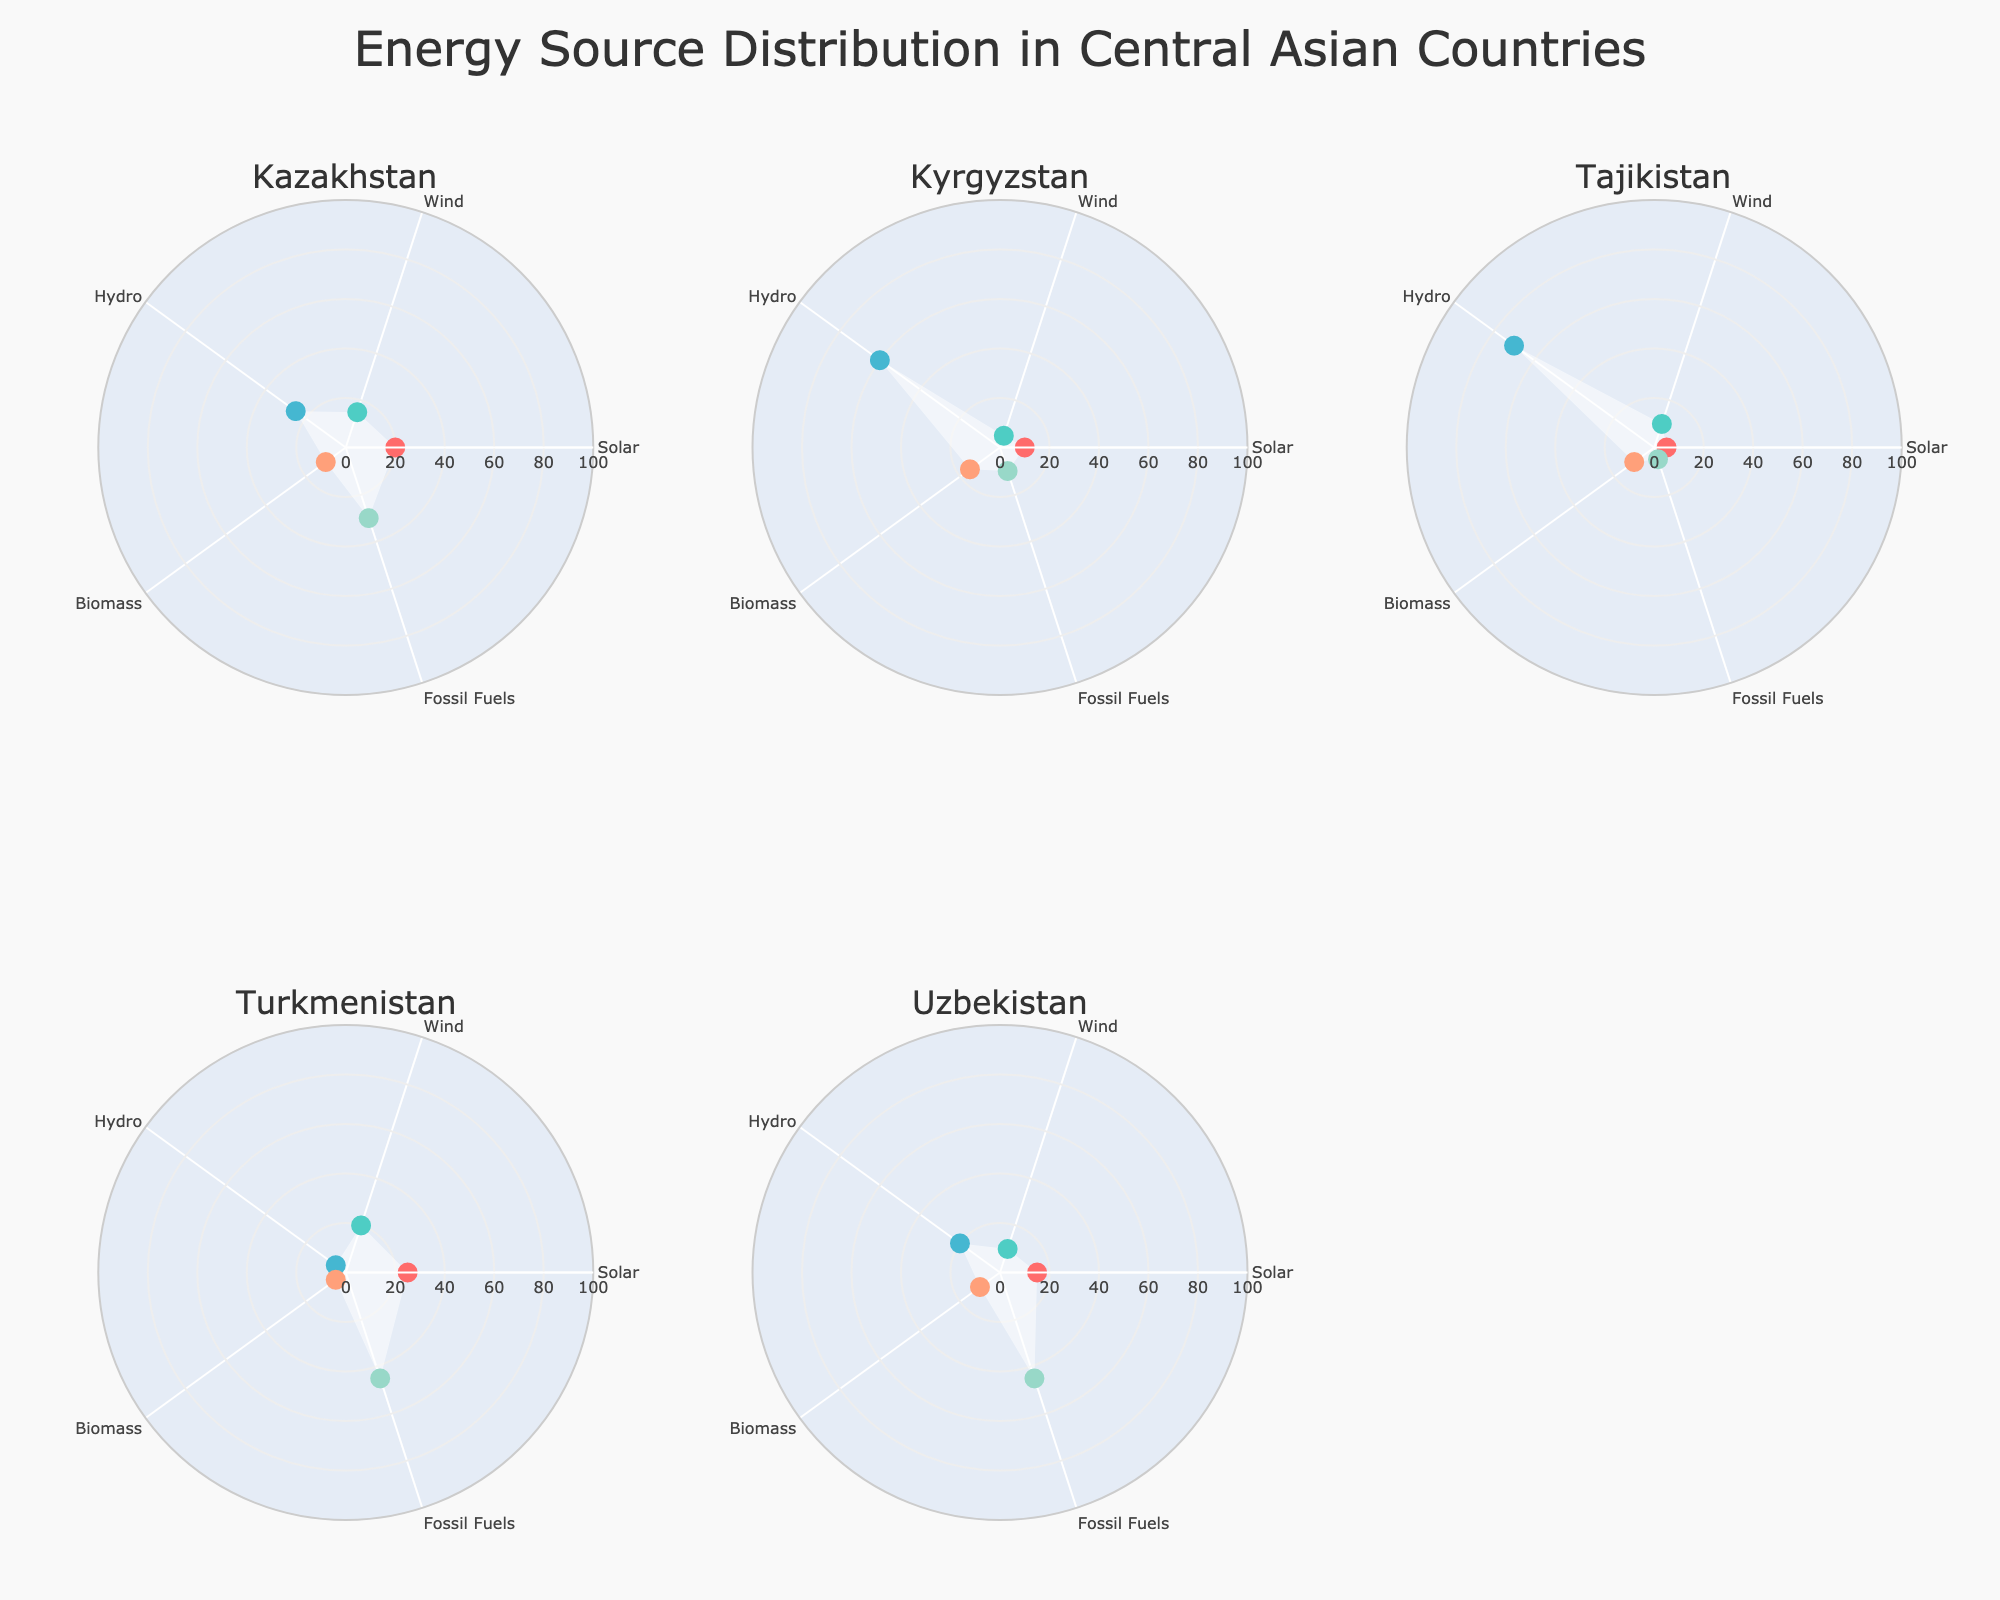Which country has the highest percentage of energy from solar sources? The solar energy percentages are Kazakhstan (20%), Kyrgyzstan (10%), Tajikistan (5%), Turkmenistan (25%), and Uzbekistan (15%). Turkmenistan has the highest percentage at 25%.
Answer: Turkmenistan Which country relies the most on hydro energy? The hydro energy percentages are Kazakhstan (25%), Kyrgyzstan (60%), Tajikistan (70%), Turkmenistan (5%), and Uzbekistan (20%). Tajikistan has the highest percentage at 70%.
Answer: Tajikistan What is the combined percentage of wind and biomass energy in Uzbekistan? The wind energy percentage in Uzbekistan is 10%, and the biomass energy percentage is 10%. The combined percentage is 10% + 10% = 20%.
Answer: 20% How does the percentage of fossil fuel usage in Kazakhstan compare to that in Uzbekistan? The fossil fuel usage is 30% for Kazakhstan and 45% for Uzbekistan, so Uzbekistan uses a higher percentage of fossil fuels than Kazakhstan.
Answer: Uzbekistan uses more Which energy source is the least utilized across all countries? By examining each polar chart, the lowest percentages of usage are for wind energy in Kyrgyzstan (5%), hydro energy in Turkmenistan (5%), and fossil fuels in Tajikistan (5%). Comparing these, the least utilized source across all countries is hydro energy in Turkmenistan and fossil fuels in Tajikistan, both at 5%.
Answer: Hydro in Turkmenistan & Fossil fuels in Tajikistan What is the average percentage utilization of solar energy in Central Asia? The solar energy percentages for the countries are Kazakhstan (20%), Kyrgyzstan (10%), Tajikistan (5%), Turkmenistan (25%), and Uzbekistan (15%). The average is calculated as (20% + 10% + 5% + 25% + 15%) / 5 = 15%.
Answer: 15% Rank the countries by their percentage of wind energy utilization from highest to lowest. The wind energy percentages are Turkmenistan (20%), Tajikistan (10%), Kazakhstan (15%), Uzbekistan (10%), and Kyrgyzstan (5%). Ordered from highest to lowest: Turkmenistan (20%), Kazakhstan (15%), Tajikistan (10%), Uzbekistan (10%), Kyrgyzstan (5%).
Answer: Turkmenistan, Kazakhstan, Tajikistan, Uzbekistan, Kyrgyzstan In which country is the percentage of biomass energy the highest? The biomass energy percentages are Kazakhstan (10%), Kyrgyzstan (15%), Tajikistan (10%), Turkmenistan (5%), and Uzbekistan (10%). Kyrgyzstan has the highest percentage at 15%.
Answer: Kyrgyzstan 